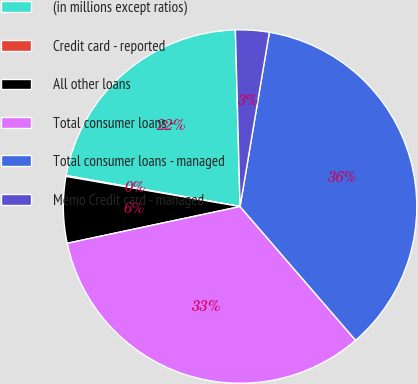Convert chart. <chart><loc_0><loc_0><loc_500><loc_500><pie_chart><fcel>(in millions except ratios)<fcel>Credit card - reported<fcel>All other loans<fcel>Total consumer loans -<fcel>Total consumer loans - managed<fcel>Memo Credit card - managed<nl><fcel>21.77%<fcel>0.08%<fcel>6.06%<fcel>33.01%<fcel>36.01%<fcel>3.07%<nl></chart> 